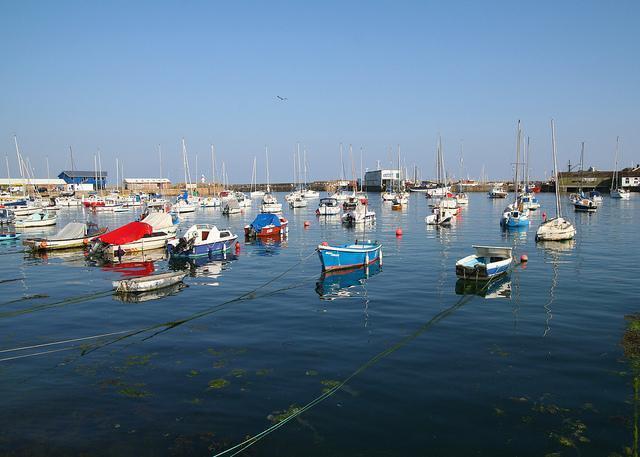These items that are moving can be referred to as being part of what?
Answer the question by selecting the correct answer among the 4 following choices.
Options: School, fleet, clowder, database. Fleet. 